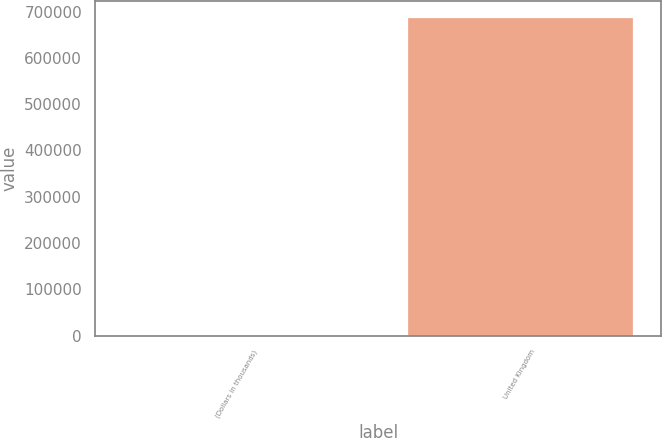<chart> <loc_0><loc_0><loc_500><loc_500><bar_chart><fcel>(Dollars in thousands)<fcel>United Kingdom<nl><fcel>2016<fcel>688598<nl></chart> 